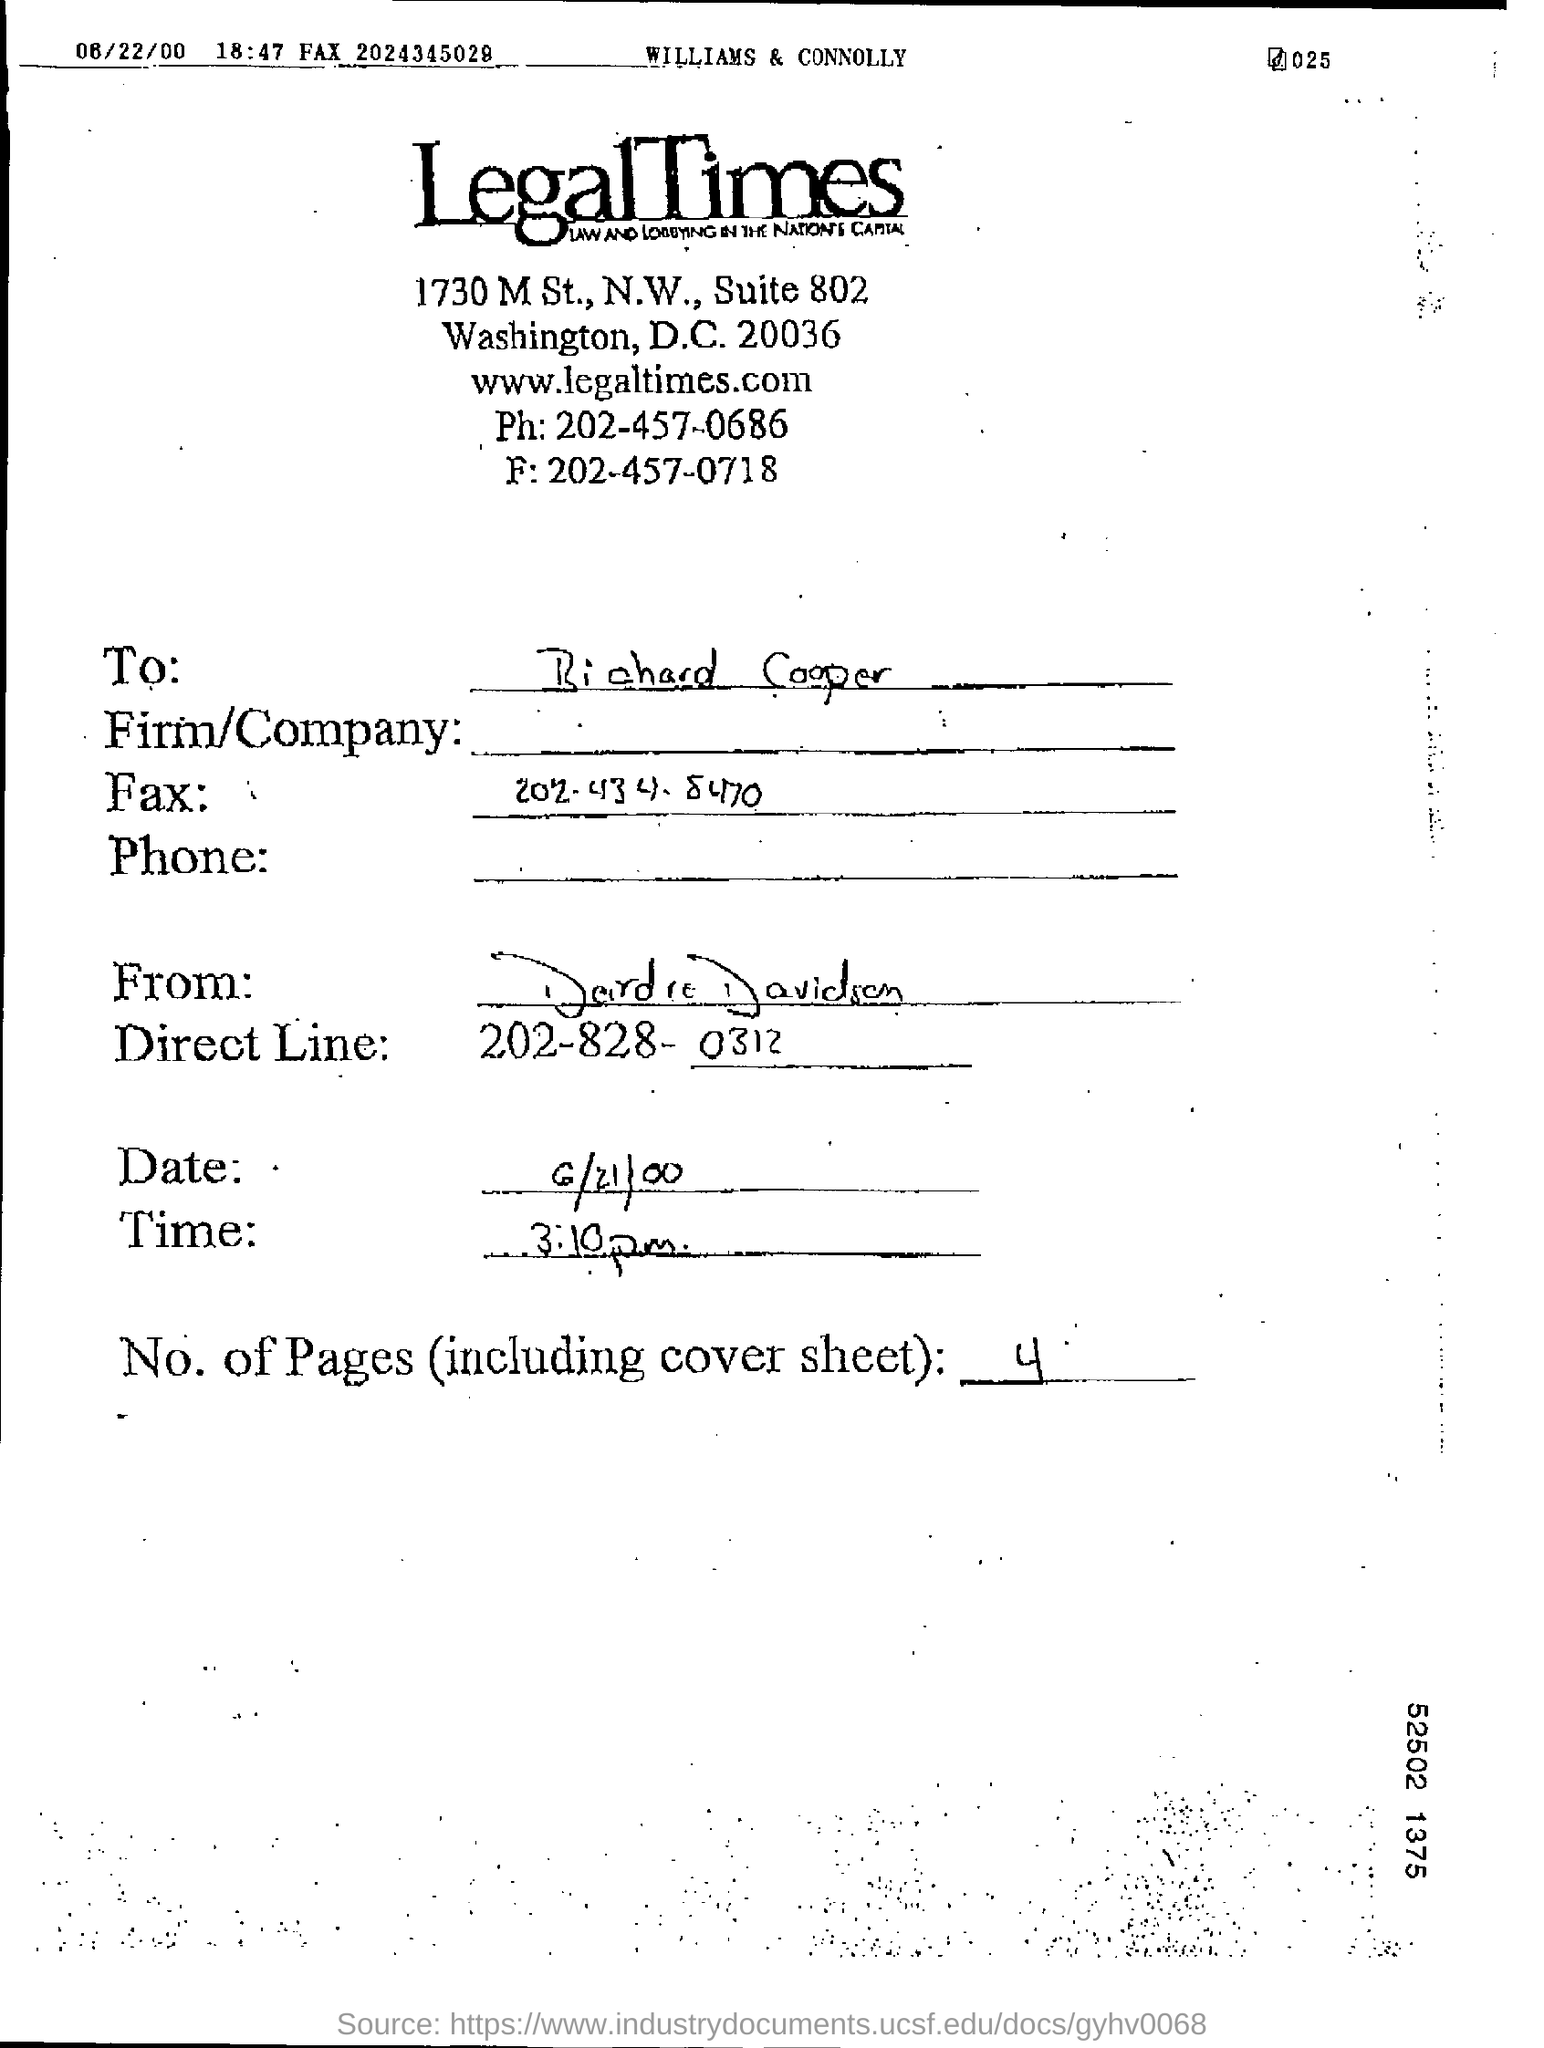What is the direct line in this document?
Keep it short and to the point. 202-828-0312. How many pages are including coversheet in this document?
Your response must be concise. 4. 